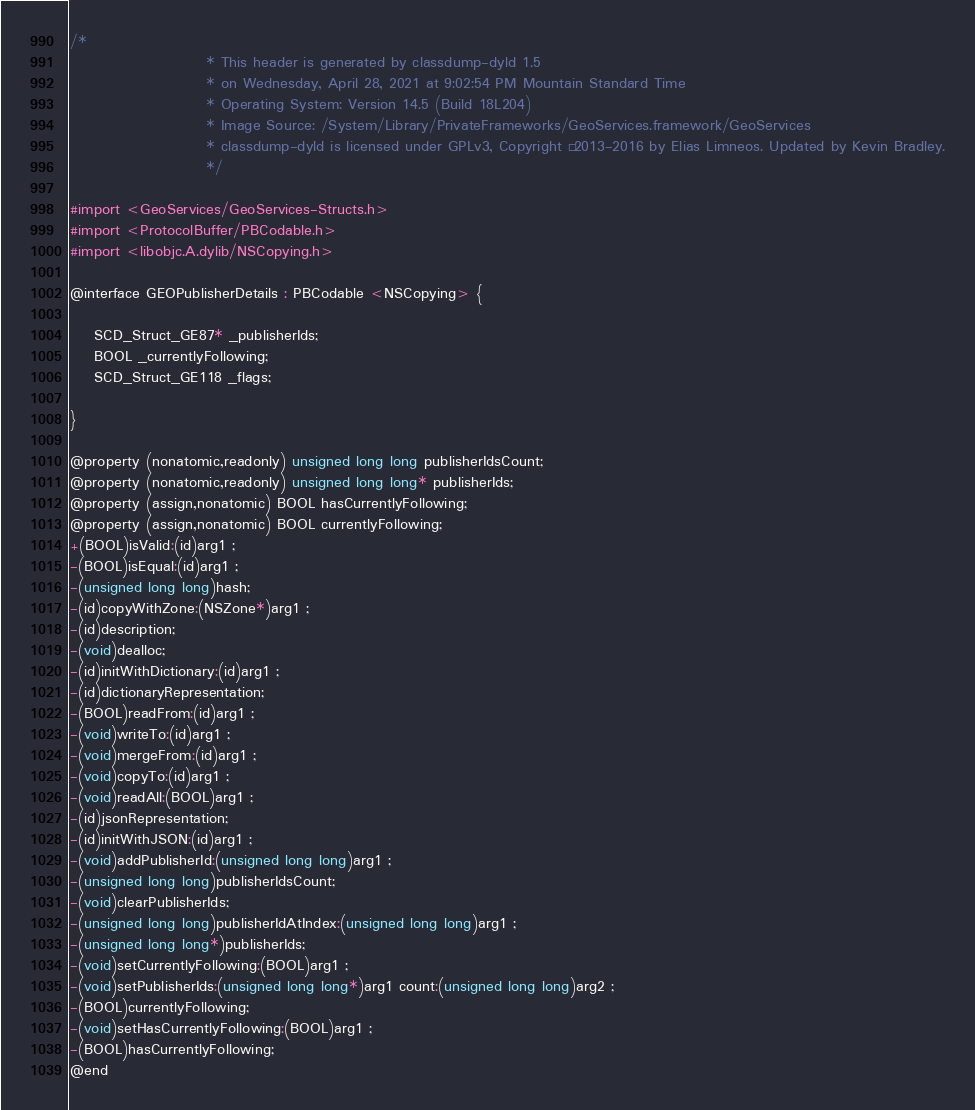<code> <loc_0><loc_0><loc_500><loc_500><_C_>/*
                       * This header is generated by classdump-dyld 1.5
                       * on Wednesday, April 28, 2021 at 9:02:54 PM Mountain Standard Time
                       * Operating System: Version 14.5 (Build 18L204)
                       * Image Source: /System/Library/PrivateFrameworks/GeoServices.framework/GeoServices
                       * classdump-dyld is licensed under GPLv3, Copyright © 2013-2016 by Elias Limneos. Updated by Kevin Bradley.
                       */

#import <GeoServices/GeoServices-Structs.h>
#import <ProtocolBuffer/PBCodable.h>
#import <libobjc.A.dylib/NSCopying.h>

@interface GEOPublisherDetails : PBCodable <NSCopying> {

	SCD_Struct_GE87* _publisherIds;
	BOOL _currentlyFollowing;
	SCD_Struct_GE118 _flags;

}

@property (nonatomic,readonly) unsigned long long publisherIdsCount; 
@property (nonatomic,readonly) unsigned long long* publisherIds; 
@property (assign,nonatomic) BOOL hasCurrentlyFollowing; 
@property (assign,nonatomic) BOOL currentlyFollowing; 
+(BOOL)isValid:(id)arg1 ;
-(BOOL)isEqual:(id)arg1 ;
-(unsigned long long)hash;
-(id)copyWithZone:(NSZone*)arg1 ;
-(id)description;
-(void)dealloc;
-(id)initWithDictionary:(id)arg1 ;
-(id)dictionaryRepresentation;
-(BOOL)readFrom:(id)arg1 ;
-(void)writeTo:(id)arg1 ;
-(void)mergeFrom:(id)arg1 ;
-(void)copyTo:(id)arg1 ;
-(void)readAll:(BOOL)arg1 ;
-(id)jsonRepresentation;
-(id)initWithJSON:(id)arg1 ;
-(void)addPublisherId:(unsigned long long)arg1 ;
-(unsigned long long)publisherIdsCount;
-(void)clearPublisherIds;
-(unsigned long long)publisherIdAtIndex:(unsigned long long)arg1 ;
-(unsigned long long*)publisherIds;
-(void)setCurrentlyFollowing:(BOOL)arg1 ;
-(void)setPublisherIds:(unsigned long long*)arg1 count:(unsigned long long)arg2 ;
-(BOOL)currentlyFollowing;
-(void)setHasCurrentlyFollowing:(BOOL)arg1 ;
-(BOOL)hasCurrentlyFollowing;
@end

</code> 